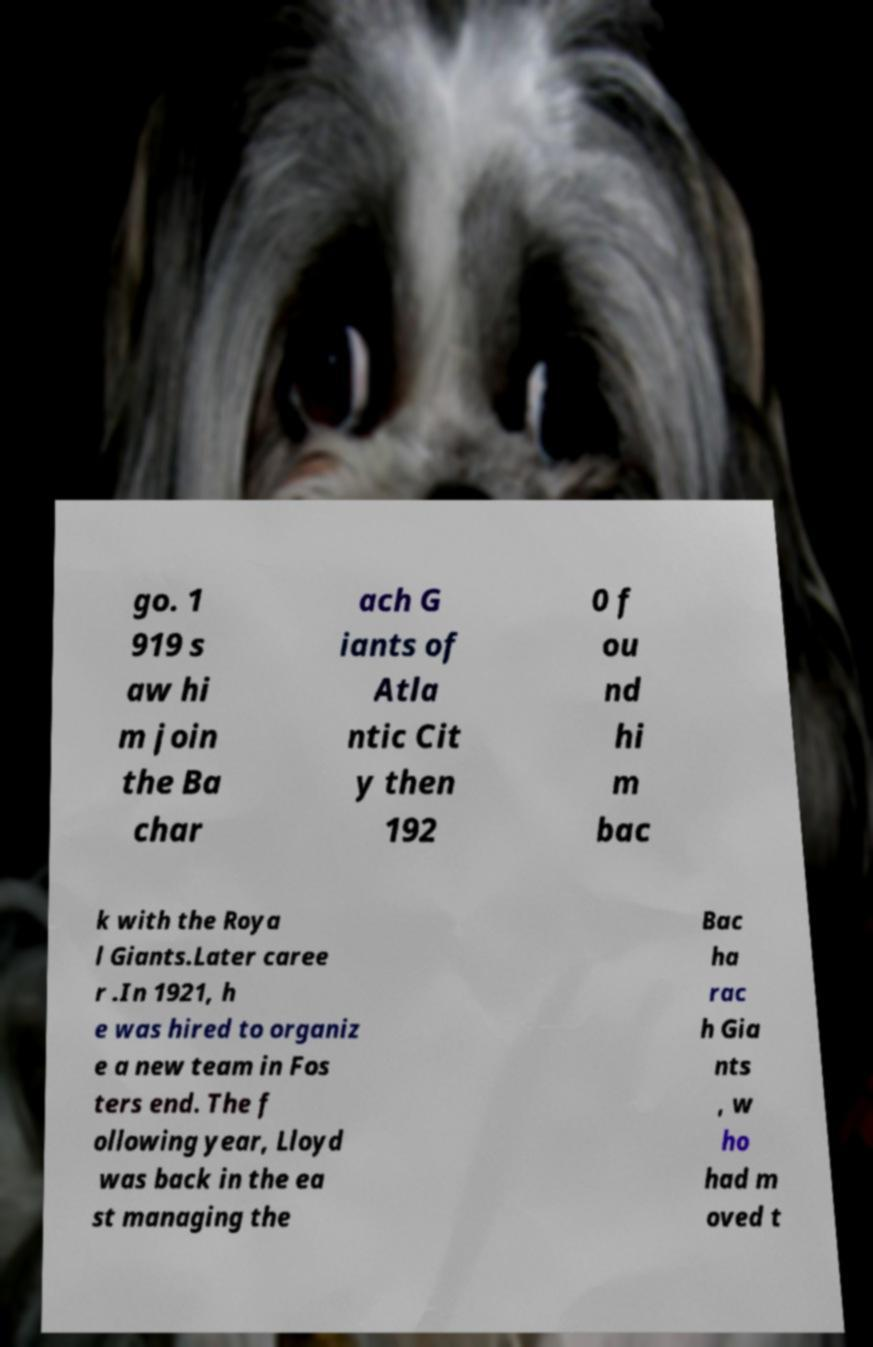What messages or text are displayed in this image? I need them in a readable, typed format. go. 1 919 s aw hi m join the Ba char ach G iants of Atla ntic Cit y then 192 0 f ou nd hi m bac k with the Roya l Giants.Later caree r .In 1921, h e was hired to organiz e a new team in Fos ters end. The f ollowing year, Lloyd was back in the ea st managing the Bac ha rac h Gia nts , w ho had m oved t 